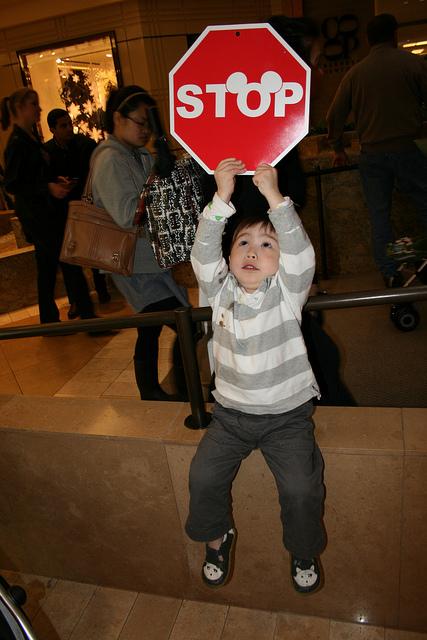What color is the toddlers shirt?
Concise answer only. Gray and white. What is the child holding?
Write a very short answer. Stop sign. What character does the 'O' on the sign resemble?
Write a very short answer. Mickey mouse. What kind of material is the floor made of?
Answer briefly. Tile. 